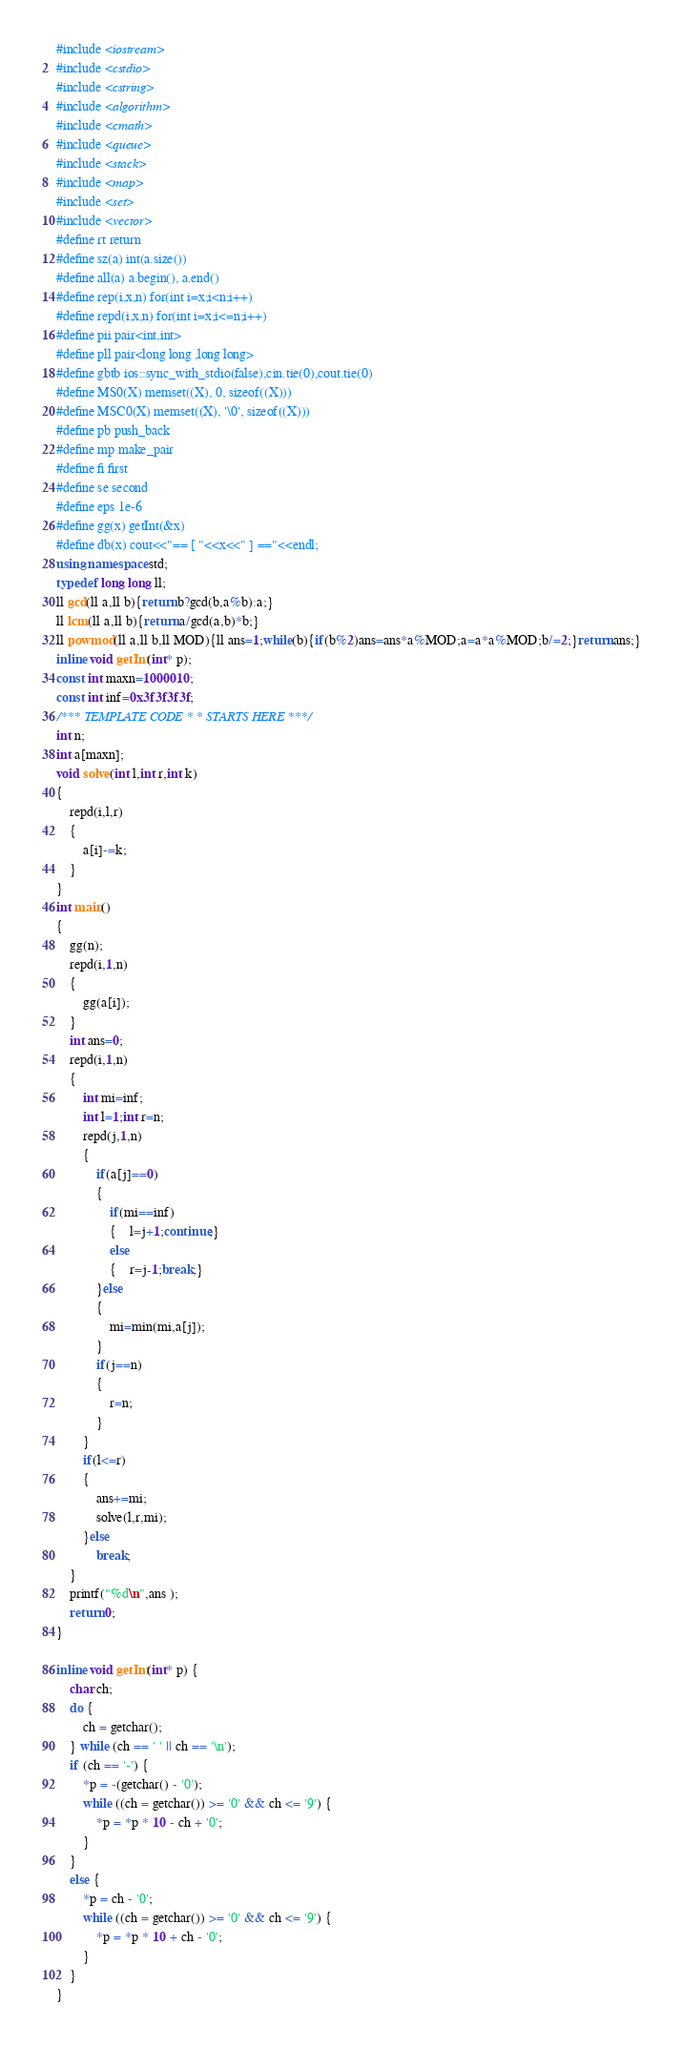Convert code to text. <code><loc_0><loc_0><loc_500><loc_500><_C++_>#include <iostream>
#include <cstdio>
#include <cstring>
#include <algorithm>
#include <cmath>
#include <queue>
#include <stack>
#include <map>
#include <set>
#include <vector>
#define rt return
#define sz(a) int(a.size())
#define all(a) a.begin(), a.end()
#define rep(i,x,n) for(int i=x;i<n;i++)
#define repd(i,x,n) for(int i=x;i<=n;i++)
#define pii pair<int,int>
#define pll pair<long long ,long long>
#define gbtb ios::sync_with_stdio(false),cin.tie(0),cout.tie(0)
#define MS0(X) memset((X), 0, sizeof((X)))
#define MSC0(X) memset((X), '\0', sizeof((X)))
#define pb push_back
#define mp make_pair
#define fi first
#define se second
#define eps 1e-6
#define gg(x) getInt(&x)
#define db(x) cout<<"== [ "<<x<<" ] =="<<endl;
using namespace std;
typedef long long ll;
ll gcd(ll a,ll b){return b?gcd(b,a%b):a;}
ll lcm(ll a,ll b){return a/gcd(a,b)*b;}
ll powmod(ll a,ll b,ll MOD){ll ans=1;while(b){if(b%2)ans=ans*a%MOD;a=a*a%MOD;b/=2;}return ans;}
inline void getInt(int* p);
const int maxn=1000010;
const int inf=0x3f3f3f3f;
/*** TEMPLATE CODE * * STARTS HERE ***/
int n;
int a[maxn];
void solve(int l,int r,int k)
{
	repd(i,l,r)
	{
		a[i]-=k;
	}
}
int main()
{
    gg(n);
    repd(i,1,n)
    {
    	gg(a[i]);
    }
    int ans=0;
    repd(i,1,n)
    {
    	int mi=inf;
    	int l=1;int r=n;
    	repd(j,1,n)
    	{
    		if(a[j]==0)
    		{
    			if(mi==inf)
    			{	l=j+1;continue;}
    			else
    			{	r=j-1;break;}
    		}else
    		{
    			mi=min(mi,a[j]);
    		}
    		if(j==n)
    		{
    			r=n;
    		}
    	}
    	if(l<=r)
    	{
    		ans+=mi;
    		solve(l,r,mi);
    	}else
            break;
    }
    printf("%d\n",ans );
    return 0;
}

inline void getInt(int* p) {
    char ch;
    do {
        ch = getchar();
    } while (ch == ' ' || ch == '\n');
    if (ch == '-') {
        *p = -(getchar() - '0');
        while ((ch = getchar()) >= '0' && ch <= '9') {
            *p = *p * 10 - ch + '0';
        }
    }
    else {
        *p = ch - '0';
        while ((ch = getchar()) >= '0' && ch <= '9') {
            *p = *p * 10 + ch - '0';
        }
    }
}

</code> 